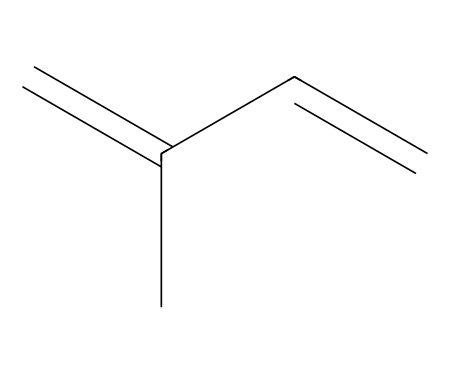What is the main type of functional group present in this structure? The structure contains double bonds between carbon atoms, indicating that it is an alkene. Alkenes are characterized by the presence of one or more carbon-carbon double bonds.
Answer: alkene How many carbon atoms are present in this molecule? By analyzing the SMILES representation, there are four carbon atoms indicated by 'C' in the structure.
Answer: four What is the total number of double bonds in this chemical structure? The SMILES shows two double bonds (C=C) between carbon atoms, confirming that this structure contains two double bonds.
Answer: two What type of polymer is formed from this monomer? This monomer can undergo polymerization to form a polyolefin, which is a type of addition polymer derived from an alkene.
Answer: polyolefin How does the structure of this monomer contribute to the elasticity of rubber? The presence of double bonds allows for cross-linking during polymerization, which provides flexibility and stretch, contributing to the overall elasticity of rubber used in tennis ball cores.
Answer: elasticity Which two types of reactions can this monomer participate in? The double bonds in the structure allow the monomer to participate in addition reactions, and also in polymerization reactions where it can link with other monomers to form long chains.
Answer: addition and polymerization 